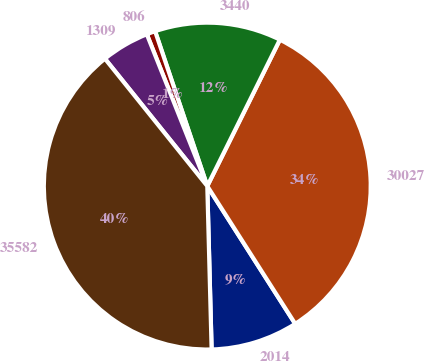Convert chart. <chart><loc_0><loc_0><loc_500><loc_500><pie_chart><fcel>2014<fcel>30027<fcel>3440<fcel>806<fcel>1309<fcel>35582<nl><fcel>8.62%<fcel>33.63%<fcel>12.5%<fcel>0.86%<fcel>4.74%<fcel>39.65%<nl></chart> 